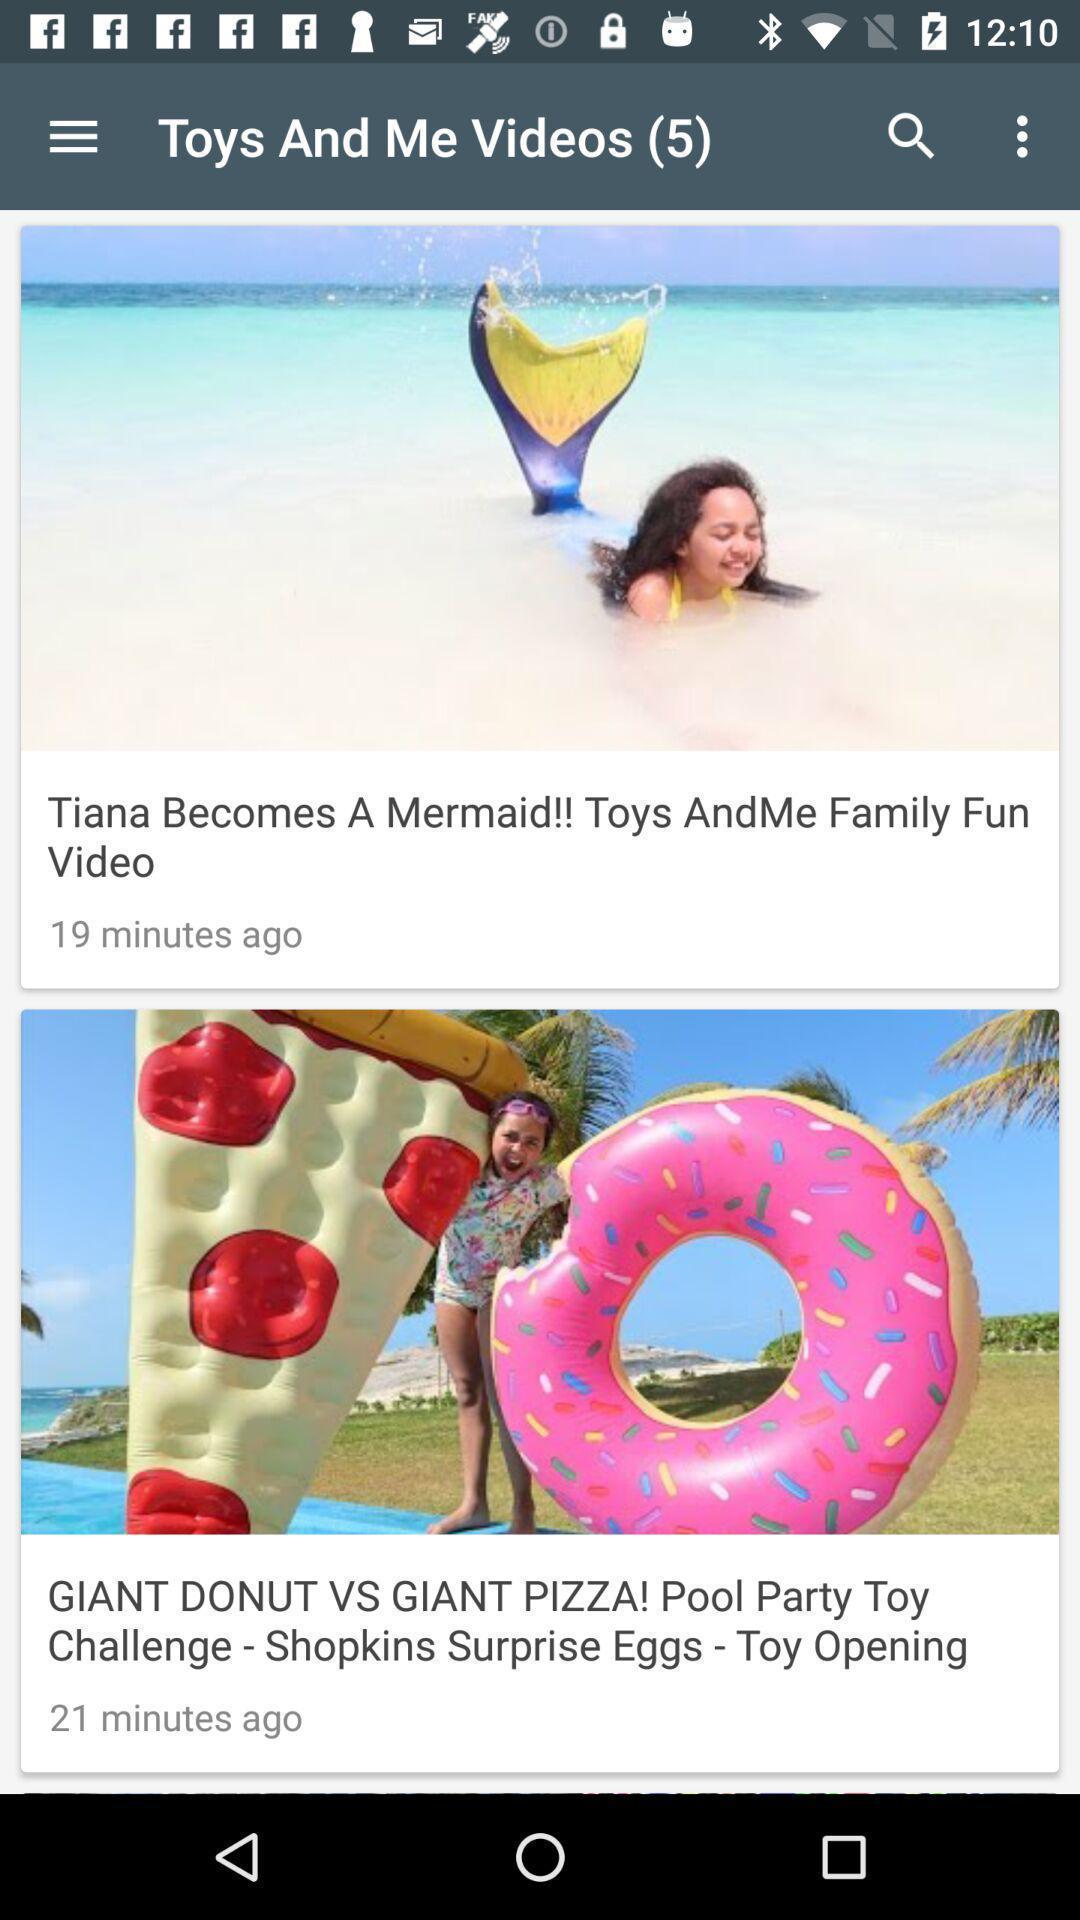Describe this image in words. Various feed displayed. 